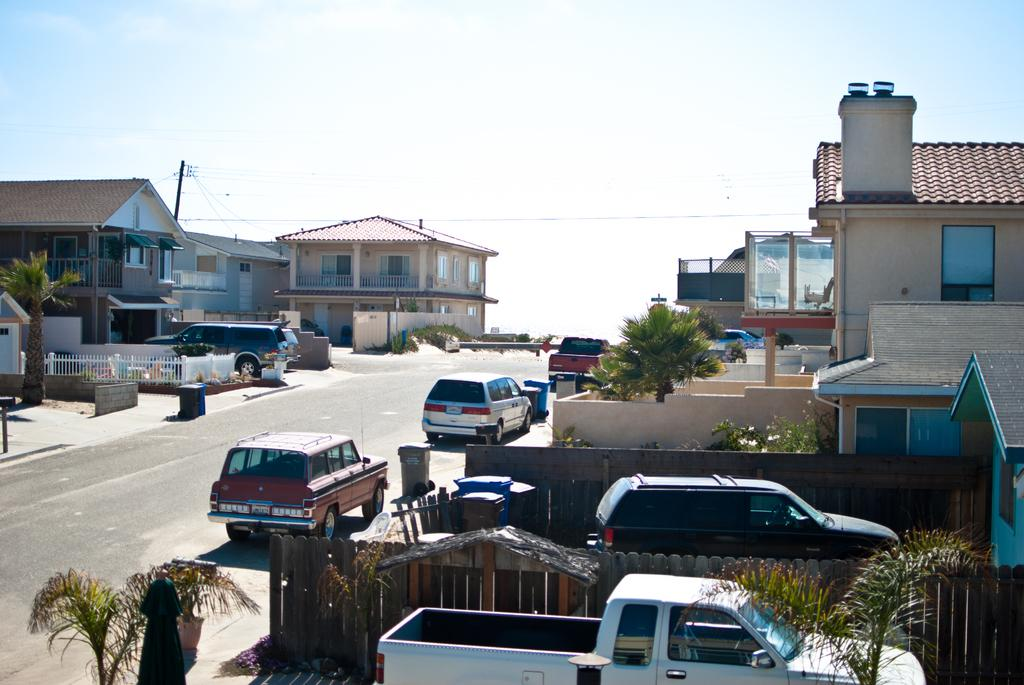What type of structures can be seen in the image? There are many buildings in the image. What type of vehicles are present in the image? There are cars in the image. Where are the cars located in the image? The cars are parked on a road in the image. What type of vegetation is near the houses in the image? Small trees are present near the houses. What is visible at the top of the image? The sky is visible at the top of the image. What type of substance is being used by the achiever in the image? There is no achiever or substance present in the image. What color is the ink used for writing on the trees in the image? There is no ink or writing on the trees in the image. 